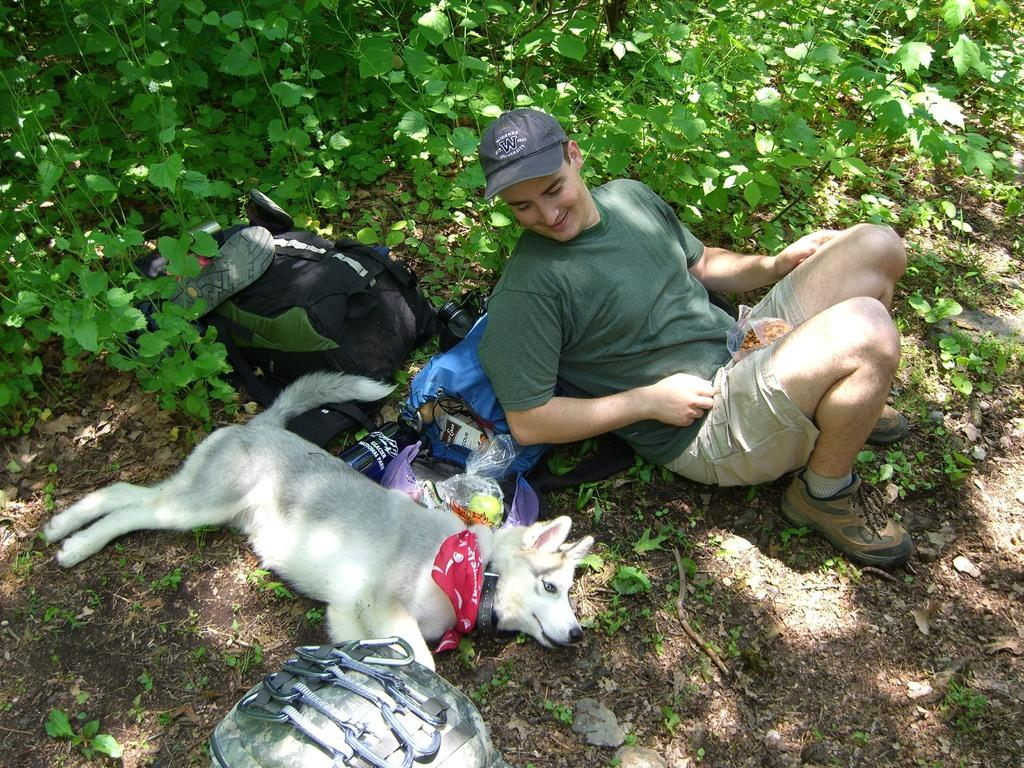Where was the image taken? The image is taken outdoors. What is happening on the floor in the image? There is a man and a dog lying on the floor in the image. What is located behind the man in the image? There is a bag behind the man in the image. What type of natural elements can be seen in the image? There are plants visible in the image. What type of vessel is being used by the governor in the image? There is no governor or vessel present in the image. 